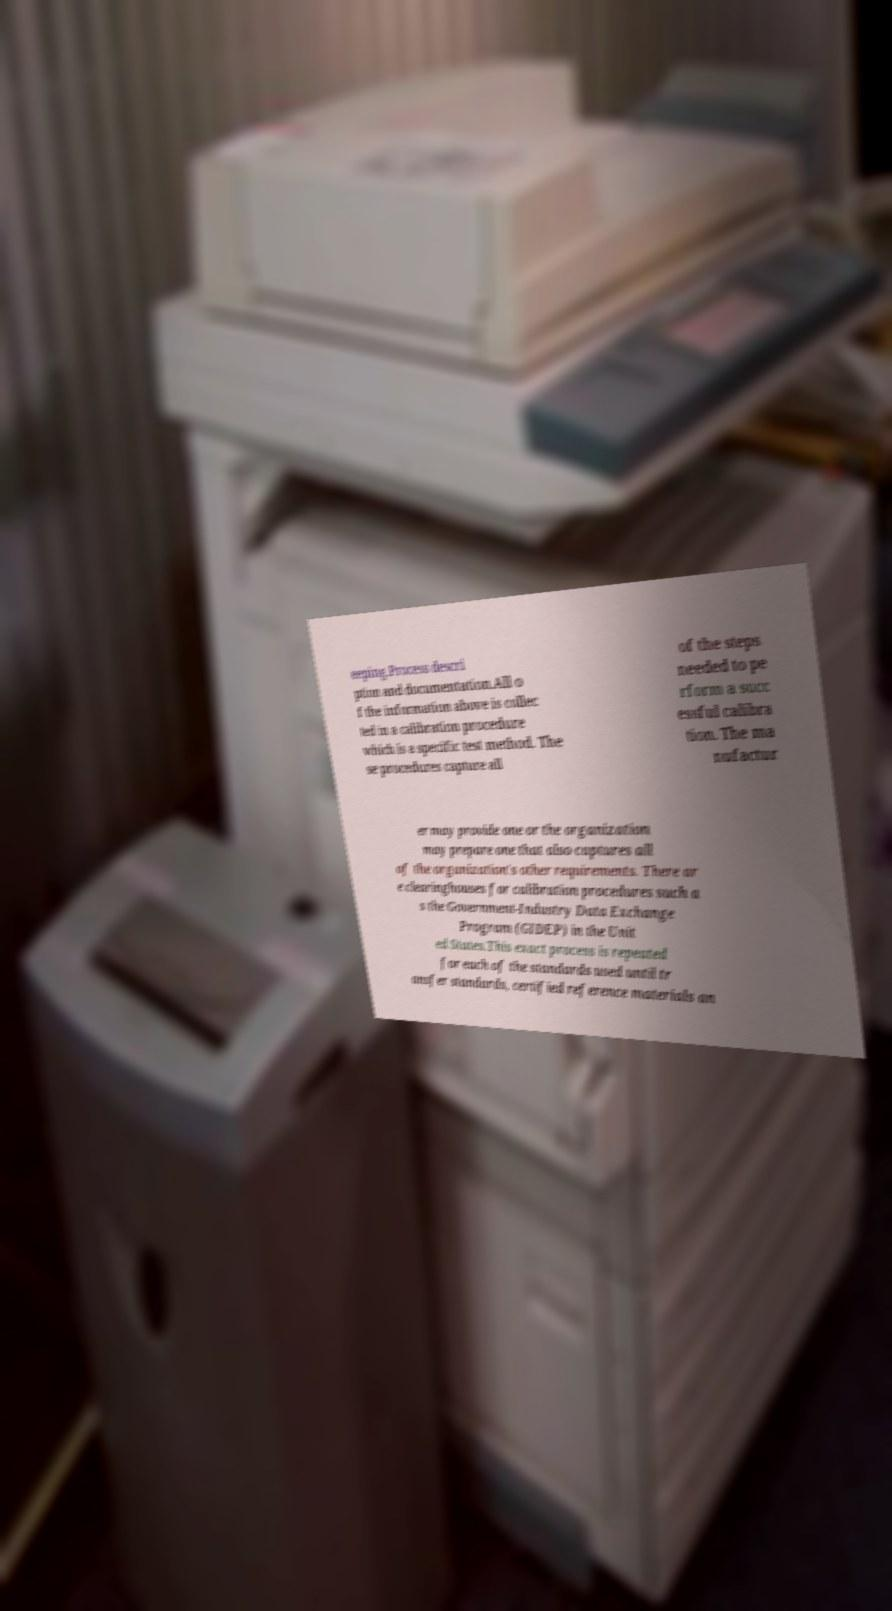Please read and relay the text visible in this image. What does it say? eeping.Process descri ption and documentation.All o f the information above is collec ted in a calibration procedure which is a specific test method. The se procedures capture all of the steps needed to pe rform a succ essful calibra tion. The ma nufactur er may provide one or the organization may prepare one that also captures all of the organization's other requirements. There ar e clearinghouses for calibration procedures such a s the Government-Industry Data Exchange Program (GIDEP) in the Unit ed States.This exact process is repeated for each of the standards used until tr ansfer standards, certified reference materials an 